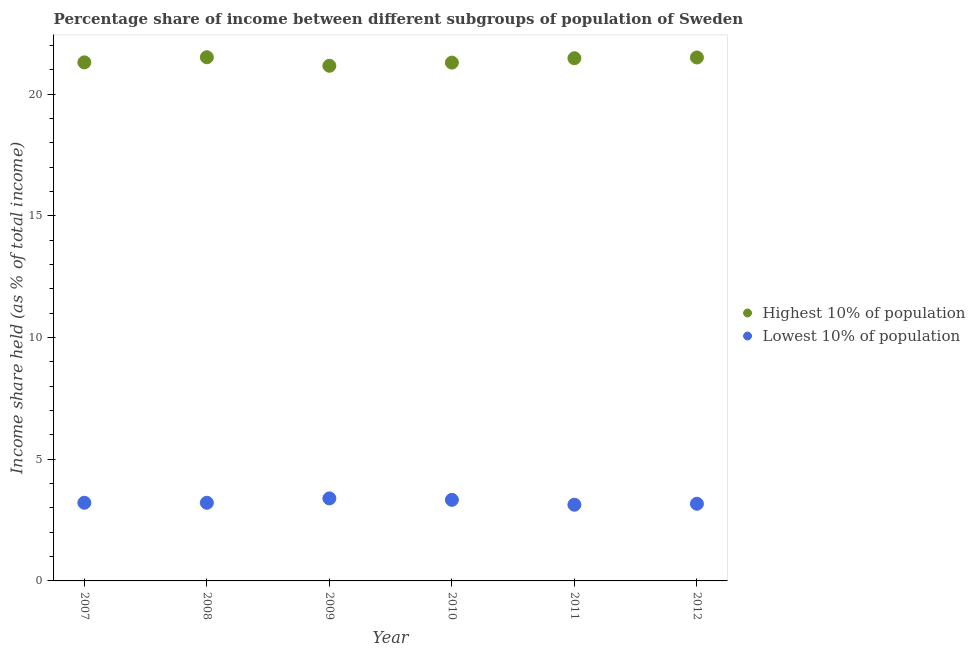What is the income share held by lowest 10% of the population in 2011?
Your answer should be compact. 3.13. Across all years, what is the maximum income share held by highest 10% of the population?
Provide a short and direct response. 21.51. Across all years, what is the minimum income share held by highest 10% of the population?
Provide a succinct answer. 21.16. In which year was the income share held by lowest 10% of the population maximum?
Offer a very short reply. 2009. In which year was the income share held by lowest 10% of the population minimum?
Your answer should be very brief. 2011. What is the total income share held by highest 10% of the population in the graph?
Ensure brevity in your answer.  128.23. What is the difference between the income share held by highest 10% of the population in 2010 and that in 2012?
Keep it short and to the point. -0.21. What is the difference between the income share held by lowest 10% of the population in 2010 and the income share held by highest 10% of the population in 2009?
Keep it short and to the point. -17.83. What is the average income share held by highest 10% of the population per year?
Your response must be concise. 21.37. What is the ratio of the income share held by highest 10% of the population in 2009 to that in 2010?
Offer a very short reply. 0.99. What is the difference between the highest and the second highest income share held by lowest 10% of the population?
Give a very brief answer. 0.06. What is the difference between the highest and the lowest income share held by lowest 10% of the population?
Offer a very short reply. 0.26. Is the sum of the income share held by lowest 10% of the population in 2011 and 2012 greater than the maximum income share held by highest 10% of the population across all years?
Ensure brevity in your answer.  No. Does the income share held by lowest 10% of the population monotonically increase over the years?
Give a very brief answer. No. Is the income share held by lowest 10% of the population strictly greater than the income share held by highest 10% of the population over the years?
Your response must be concise. No. How many years are there in the graph?
Offer a terse response. 6. Are the values on the major ticks of Y-axis written in scientific E-notation?
Make the answer very short. No. Does the graph contain any zero values?
Provide a succinct answer. No. How many legend labels are there?
Your response must be concise. 2. How are the legend labels stacked?
Keep it short and to the point. Vertical. What is the title of the graph?
Offer a terse response. Percentage share of income between different subgroups of population of Sweden. What is the label or title of the X-axis?
Your answer should be very brief. Year. What is the label or title of the Y-axis?
Your response must be concise. Income share held (as % of total income). What is the Income share held (as % of total income) of Highest 10% of population in 2007?
Offer a terse response. 21.3. What is the Income share held (as % of total income) in Lowest 10% of population in 2007?
Your response must be concise. 3.21. What is the Income share held (as % of total income) in Highest 10% of population in 2008?
Provide a succinct answer. 21.51. What is the Income share held (as % of total income) in Lowest 10% of population in 2008?
Your answer should be very brief. 3.21. What is the Income share held (as % of total income) of Highest 10% of population in 2009?
Your answer should be very brief. 21.16. What is the Income share held (as % of total income) of Lowest 10% of population in 2009?
Your response must be concise. 3.39. What is the Income share held (as % of total income) in Highest 10% of population in 2010?
Provide a short and direct response. 21.29. What is the Income share held (as % of total income) in Lowest 10% of population in 2010?
Your response must be concise. 3.33. What is the Income share held (as % of total income) in Highest 10% of population in 2011?
Give a very brief answer. 21.47. What is the Income share held (as % of total income) in Lowest 10% of population in 2011?
Make the answer very short. 3.13. What is the Income share held (as % of total income) in Highest 10% of population in 2012?
Offer a terse response. 21.5. What is the Income share held (as % of total income) of Lowest 10% of population in 2012?
Give a very brief answer. 3.17. Across all years, what is the maximum Income share held (as % of total income) of Highest 10% of population?
Give a very brief answer. 21.51. Across all years, what is the maximum Income share held (as % of total income) of Lowest 10% of population?
Ensure brevity in your answer.  3.39. Across all years, what is the minimum Income share held (as % of total income) in Highest 10% of population?
Provide a short and direct response. 21.16. Across all years, what is the minimum Income share held (as % of total income) of Lowest 10% of population?
Ensure brevity in your answer.  3.13. What is the total Income share held (as % of total income) in Highest 10% of population in the graph?
Make the answer very short. 128.23. What is the total Income share held (as % of total income) in Lowest 10% of population in the graph?
Provide a short and direct response. 19.44. What is the difference between the Income share held (as % of total income) of Highest 10% of population in 2007 and that in 2008?
Your answer should be very brief. -0.21. What is the difference between the Income share held (as % of total income) of Highest 10% of population in 2007 and that in 2009?
Offer a very short reply. 0.14. What is the difference between the Income share held (as % of total income) in Lowest 10% of population in 2007 and that in 2009?
Provide a succinct answer. -0.18. What is the difference between the Income share held (as % of total income) in Highest 10% of population in 2007 and that in 2010?
Make the answer very short. 0.01. What is the difference between the Income share held (as % of total income) in Lowest 10% of population in 2007 and that in 2010?
Offer a terse response. -0.12. What is the difference between the Income share held (as % of total income) of Highest 10% of population in 2007 and that in 2011?
Ensure brevity in your answer.  -0.17. What is the difference between the Income share held (as % of total income) in Lowest 10% of population in 2007 and that in 2011?
Give a very brief answer. 0.08. What is the difference between the Income share held (as % of total income) in Highest 10% of population in 2007 and that in 2012?
Offer a very short reply. -0.2. What is the difference between the Income share held (as % of total income) of Lowest 10% of population in 2007 and that in 2012?
Provide a short and direct response. 0.04. What is the difference between the Income share held (as % of total income) of Highest 10% of population in 2008 and that in 2009?
Offer a terse response. 0.35. What is the difference between the Income share held (as % of total income) in Lowest 10% of population in 2008 and that in 2009?
Give a very brief answer. -0.18. What is the difference between the Income share held (as % of total income) in Highest 10% of population in 2008 and that in 2010?
Make the answer very short. 0.22. What is the difference between the Income share held (as % of total income) in Lowest 10% of population in 2008 and that in 2010?
Give a very brief answer. -0.12. What is the difference between the Income share held (as % of total income) of Highest 10% of population in 2008 and that in 2011?
Ensure brevity in your answer.  0.04. What is the difference between the Income share held (as % of total income) of Lowest 10% of population in 2008 and that in 2011?
Provide a succinct answer. 0.08. What is the difference between the Income share held (as % of total income) of Highest 10% of population in 2009 and that in 2010?
Keep it short and to the point. -0.13. What is the difference between the Income share held (as % of total income) in Lowest 10% of population in 2009 and that in 2010?
Your response must be concise. 0.06. What is the difference between the Income share held (as % of total income) of Highest 10% of population in 2009 and that in 2011?
Keep it short and to the point. -0.31. What is the difference between the Income share held (as % of total income) in Lowest 10% of population in 2009 and that in 2011?
Your answer should be very brief. 0.26. What is the difference between the Income share held (as % of total income) in Highest 10% of population in 2009 and that in 2012?
Your answer should be compact. -0.34. What is the difference between the Income share held (as % of total income) of Lowest 10% of population in 2009 and that in 2012?
Provide a succinct answer. 0.22. What is the difference between the Income share held (as % of total income) in Highest 10% of population in 2010 and that in 2011?
Offer a terse response. -0.18. What is the difference between the Income share held (as % of total income) of Highest 10% of population in 2010 and that in 2012?
Offer a terse response. -0.21. What is the difference between the Income share held (as % of total income) in Lowest 10% of population in 2010 and that in 2012?
Offer a terse response. 0.16. What is the difference between the Income share held (as % of total income) of Highest 10% of population in 2011 and that in 2012?
Offer a very short reply. -0.03. What is the difference between the Income share held (as % of total income) in Lowest 10% of population in 2011 and that in 2012?
Offer a very short reply. -0.04. What is the difference between the Income share held (as % of total income) in Highest 10% of population in 2007 and the Income share held (as % of total income) in Lowest 10% of population in 2008?
Your answer should be very brief. 18.09. What is the difference between the Income share held (as % of total income) in Highest 10% of population in 2007 and the Income share held (as % of total income) in Lowest 10% of population in 2009?
Make the answer very short. 17.91. What is the difference between the Income share held (as % of total income) of Highest 10% of population in 2007 and the Income share held (as % of total income) of Lowest 10% of population in 2010?
Keep it short and to the point. 17.97. What is the difference between the Income share held (as % of total income) of Highest 10% of population in 2007 and the Income share held (as % of total income) of Lowest 10% of population in 2011?
Make the answer very short. 18.17. What is the difference between the Income share held (as % of total income) of Highest 10% of population in 2007 and the Income share held (as % of total income) of Lowest 10% of population in 2012?
Provide a succinct answer. 18.13. What is the difference between the Income share held (as % of total income) in Highest 10% of population in 2008 and the Income share held (as % of total income) in Lowest 10% of population in 2009?
Give a very brief answer. 18.12. What is the difference between the Income share held (as % of total income) in Highest 10% of population in 2008 and the Income share held (as % of total income) in Lowest 10% of population in 2010?
Keep it short and to the point. 18.18. What is the difference between the Income share held (as % of total income) of Highest 10% of population in 2008 and the Income share held (as % of total income) of Lowest 10% of population in 2011?
Provide a short and direct response. 18.38. What is the difference between the Income share held (as % of total income) in Highest 10% of population in 2008 and the Income share held (as % of total income) in Lowest 10% of population in 2012?
Your answer should be very brief. 18.34. What is the difference between the Income share held (as % of total income) of Highest 10% of population in 2009 and the Income share held (as % of total income) of Lowest 10% of population in 2010?
Provide a short and direct response. 17.83. What is the difference between the Income share held (as % of total income) in Highest 10% of population in 2009 and the Income share held (as % of total income) in Lowest 10% of population in 2011?
Your answer should be very brief. 18.03. What is the difference between the Income share held (as % of total income) of Highest 10% of population in 2009 and the Income share held (as % of total income) of Lowest 10% of population in 2012?
Your answer should be very brief. 17.99. What is the difference between the Income share held (as % of total income) of Highest 10% of population in 2010 and the Income share held (as % of total income) of Lowest 10% of population in 2011?
Give a very brief answer. 18.16. What is the difference between the Income share held (as % of total income) of Highest 10% of population in 2010 and the Income share held (as % of total income) of Lowest 10% of population in 2012?
Provide a succinct answer. 18.12. What is the difference between the Income share held (as % of total income) in Highest 10% of population in 2011 and the Income share held (as % of total income) in Lowest 10% of population in 2012?
Provide a short and direct response. 18.3. What is the average Income share held (as % of total income) of Highest 10% of population per year?
Offer a very short reply. 21.37. What is the average Income share held (as % of total income) of Lowest 10% of population per year?
Your answer should be compact. 3.24. In the year 2007, what is the difference between the Income share held (as % of total income) of Highest 10% of population and Income share held (as % of total income) of Lowest 10% of population?
Your answer should be very brief. 18.09. In the year 2008, what is the difference between the Income share held (as % of total income) in Highest 10% of population and Income share held (as % of total income) in Lowest 10% of population?
Make the answer very short. 18.3. In the year 2009, what is the difference between the Income share held (as % of total income) in Highest 10% of population and Income share held (as % of total income) in Lowest 10% of population?
Provide a short and direct response. 17.77. In the year 2010, what is the difference between the Income share held (as % of total income) of Highest 10% of population and Income share held (as % of total income) of Lowest 10% of population?
Make the answer very short. 17.96. In the year 2011, what is the difference between the Income share held (as % of total income) of Highest 10% of population and Income share held (as % of total income) of Lowest 10% of population?
Give a very brief answer. 18.34. In the year 2012, what is the difference between the Income share held (as % of total income) in Highest 10% of population and Income share held (as % of total income) in Lowest 10% of population?
Give a very brief answer. 18.33. What is the ratio of the Income share held (as % of total income) of Highest 10% of population in 2007 to that in 2008?
Offer a very short reply. 0.99. What is the ratio of the Income share held (as % of total income) of Highest 10% of population in 2007 to that in 2009?
Give a very brief answer. 1.01. What is the ratio of the Income share held (as % of total income) of Lowest 10% of population in 2007 to that in 2009?
Your response must be concise. 0.95. What is the ratio of the Income share held (as % of total income) of Highest 10% of population in 2007 to that in 2010?
Keep it short and to the point. 1. What is the ratio of the Income share held (as % of total income) in Lowest 10% of population in 2007 to that in 2010?
Keep it short and to the point. 0.96. What is the ratio of the Income share held (as % of total income) of Highest 10% of population in 2007 to that in 2011?
Provide a short and direct response. 0.99. What is the ratio of the Income share held (as % of total income) of Lowest 10% of population in 2007 to that in 2011?
Offer a very short reply. 1.03. What is the ratio of the Income share held (as % of total income) of Highest 10% of population in 2007 to that in 2012?
Keep it short and to the point. 0.99. What is the ratio of the Income share held (as % of total income) in Lowest 10% of population in 2007 to that in 2012?
Keep it short and to the point. 1.01. What is the ratio of the Income share held (as % of total income) of Highest 10% of population in 2008 to that in 2009?
Your answer should be compact. 1.02. What is the ratio of the Income share held (as % of total income) in Lowest 10% of population in 2008 to that in 2009?
Give a very brief answer. 0.95. What is the ratio of the Income share held (as % of total income) of Highest 10% of population in 2008 to that in 2010?
Give a very brief answer. 1.01. What is the ratio of the Income share held (as % of total income) of Lowest 10% of population in 2008 to that in 2011?
Provide a succinct answer. 1.03. What is the ratio of the Income share held (as % of total income) in Highest 10% of population in 2008 to that in 2012?
Offer a very short reply. 1. What is the ratio of the Income share held (as % of total income) of Lowest 10% of population in 2008 to that in 2012?
Provide a succinct answer. 1.01. What is the ratio of the Income share held (as % of total income) in Lowest 10% of population in 2009 to that in 2010?
Make the answer very short. 1.02. What is the ratio of the Income share held (as % of total income) in Highest 10% of population in 2009 to that in 2011?
Keep it short and to the point. 0.99. What is the ratio of the Income share held (as % of total income) of Lowest 10% of population in 2009 to that in 2011?
Your response must be concise. 1.08. What is the ratio of the Income share held (as % of total income) in Highest 10% of population in 2009 to that in 2012?
Make the answer very short. 0.98. What is the ratio of the Income share held (as % of total income) in Lowest 10% of population in 2009 to that in 2012?
Provide a succinct answer. 1.07. What is the ratio of the Income share held (as % of total income) of Lowest 10% of population in 2010 to that in 2011?
Ensure brevity in your answer.  1.06. What is the ratio of the Income share held (as % of total income) in Highest 10% of population in 2010 to that in 2012?
Make the answer very short. 0.99. What is the ratio of the Income share held (as % of total income) in Lowest 10% of population in 2010 to that in 2012?
Give a very brief answer. 1.05. What is the ratio of the Income share held (as % of total income) in Lowest 10% of population in 2011 to that in 2012?
Offer a very short reply. 0.99. What is the difference between the highest and the lowest Income share held (as % of total income) of Lowest 10% of population?
Offer a terse response. 0.26. 